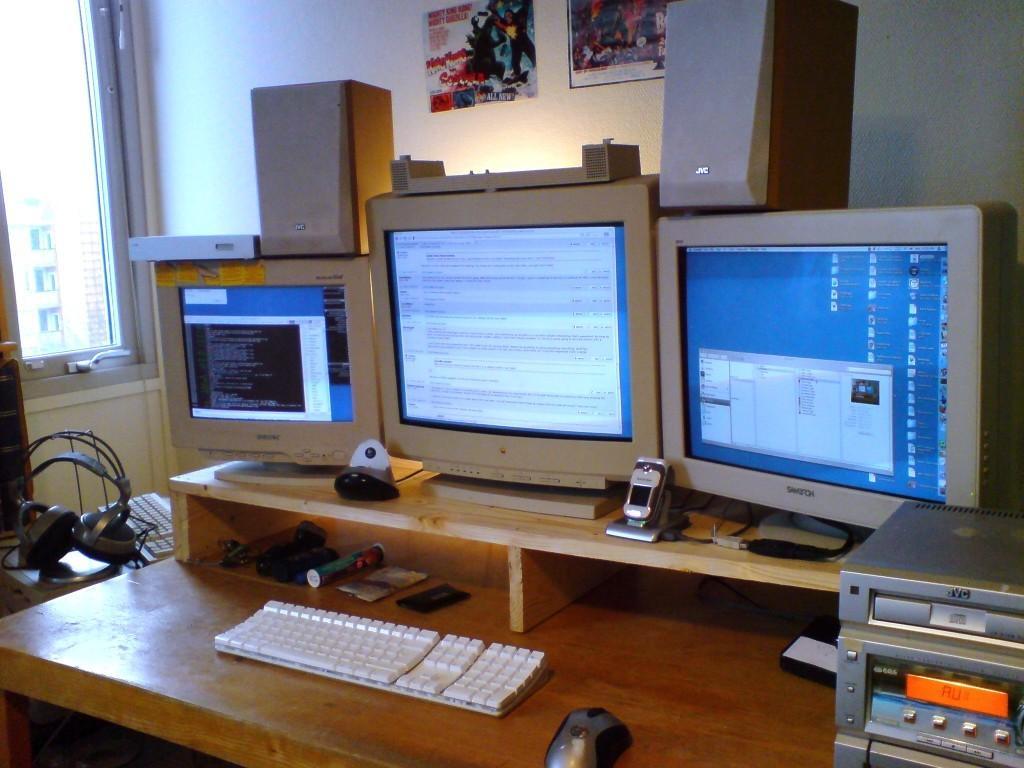In one or two sentences, can you explain what this image depicts? There is a table on the table there are computers, keyboard, mouse and some other items. In the background there is a wall. On the wall there are two notices. There is a window. On the table there are headset and another keyboard. 